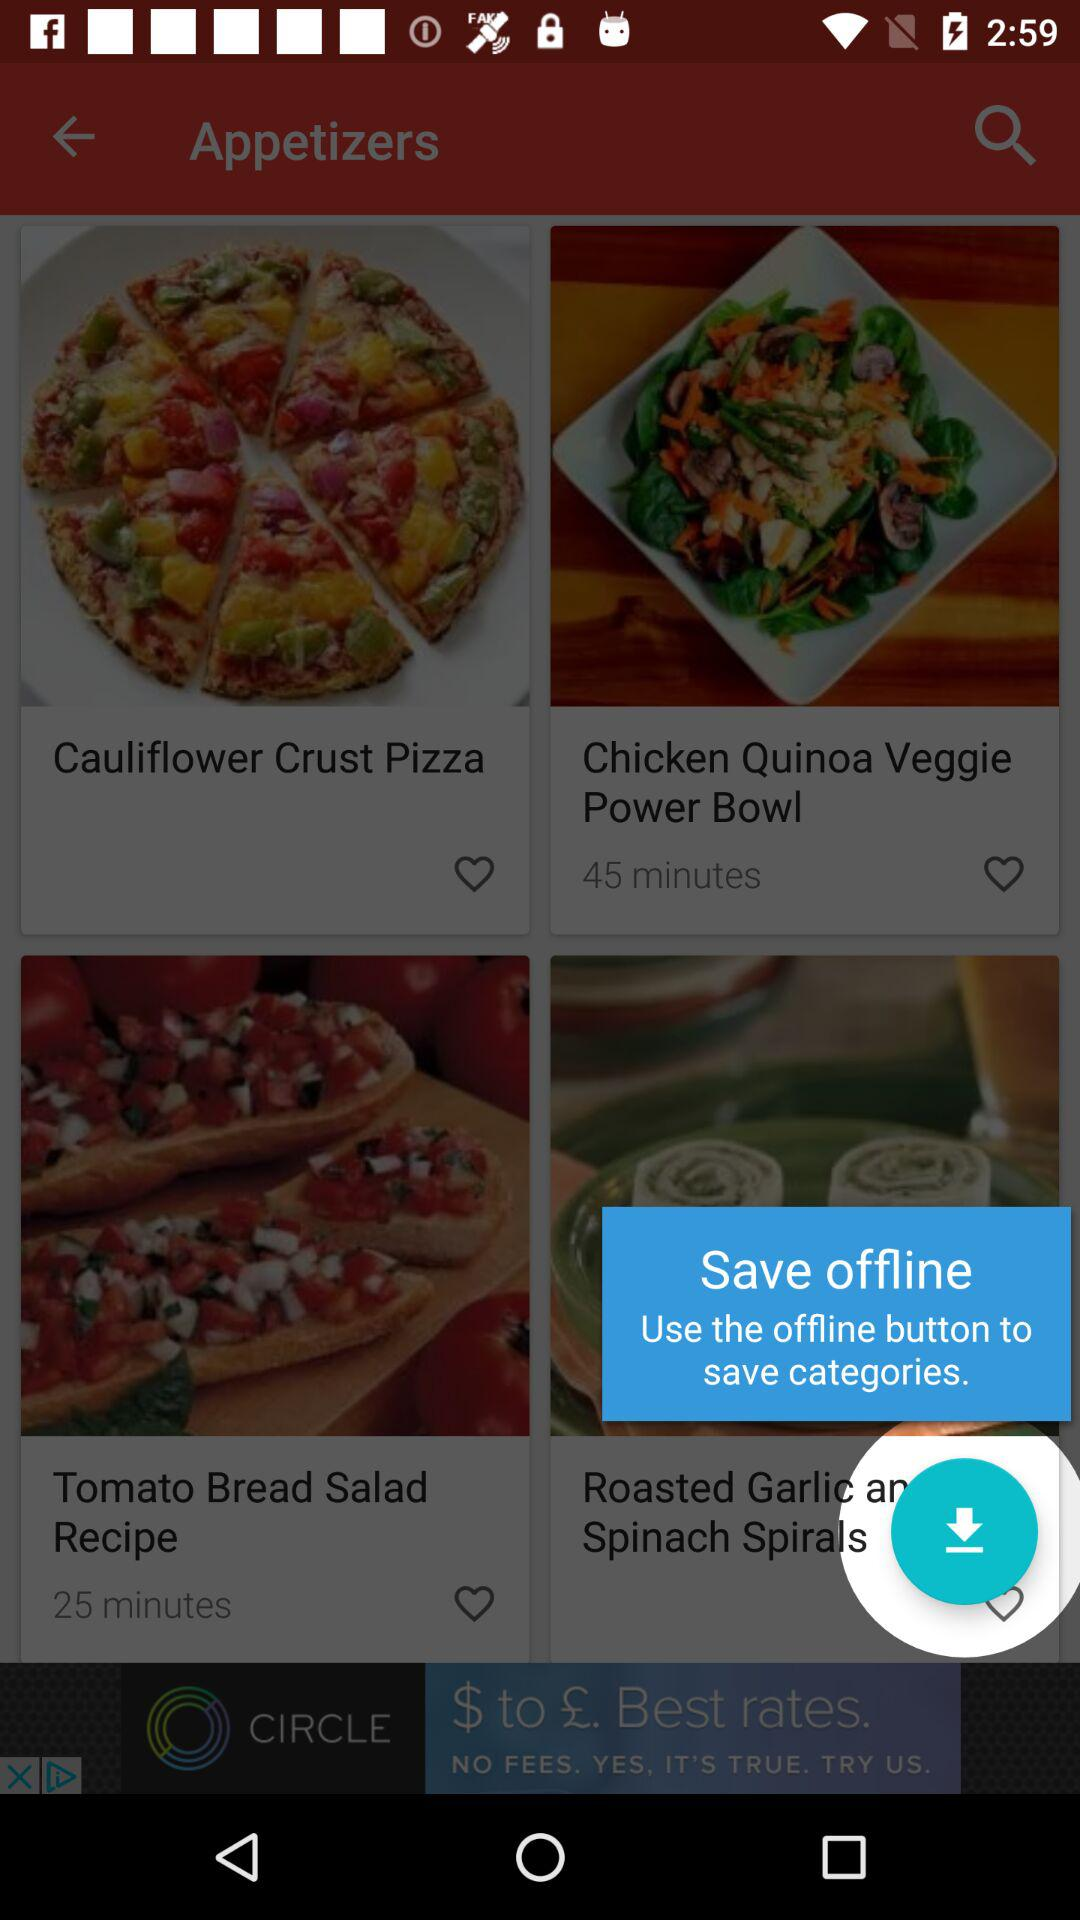How long will it take to make a "Tomato bread salad recipe"? It will take 25 minutes. 